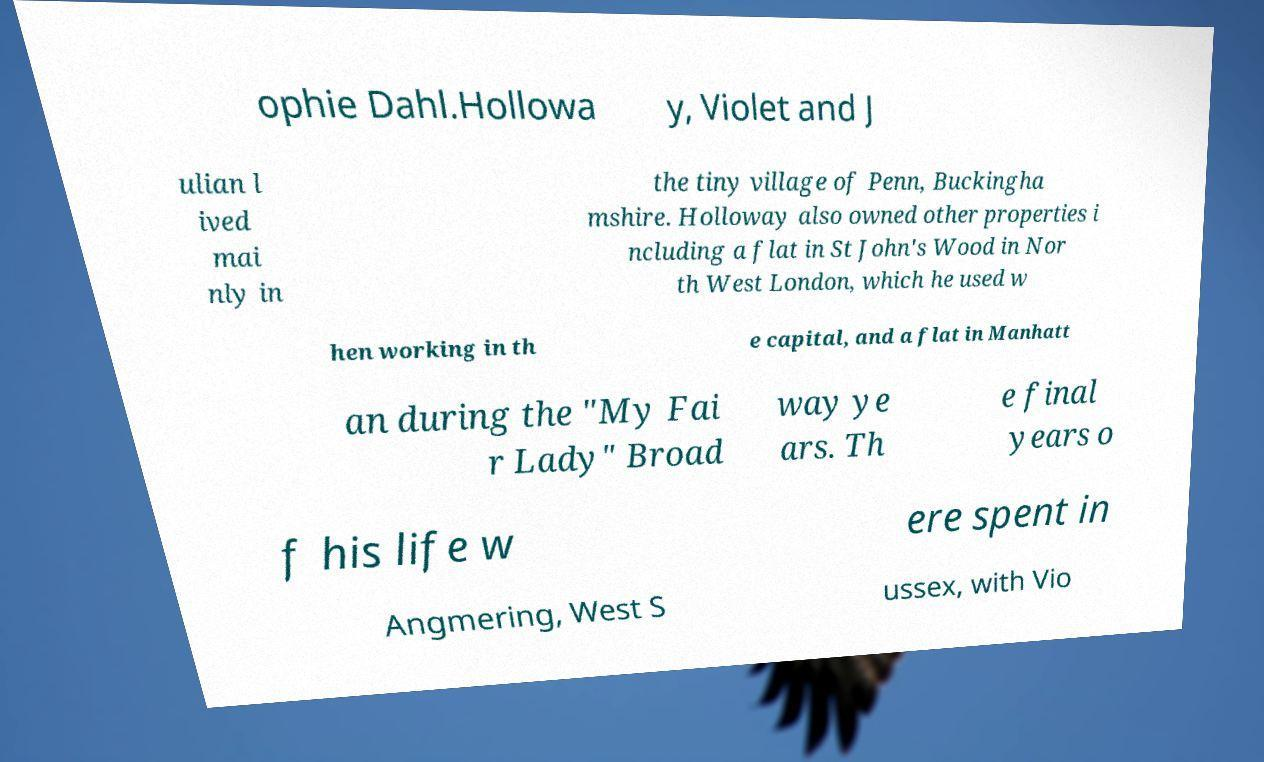There's text embedded in this image that I need extracted. Can you transcribe it verbatim? ophie Dahl.Hollowa y, Violet and J ulian l ived mai nly in the tiny village of Penn, Buckingha mshire. Holloway also owned other properties i ncluding a flat in St John's Wood in Nor th West London, which he used w hen working in th e capital, and a flat in Manhatt an during the "My Fai r Lady" Broad way ye ars. Th e final years o f his life w ere spent in Angmering, West S ussex, with Vio 